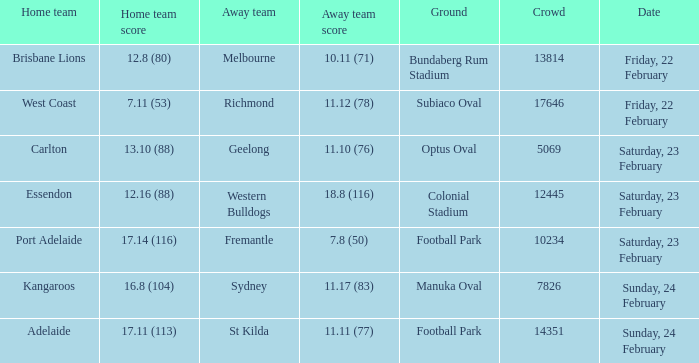Where the home team scored 13.10 (88), what was the size of the crowd? 5069.0. Parse the table in full. {'header': ['Home team', 'Home team score', 'Away team', 'Away team score', 'Ground', 'Crowd', 'Date'], 'rows': [['Brisbane Lions', '12.8 (80)', 'Melbourne', '10.11 (71)', 'Bundaberg Rum Stadium', '13814', 'Friday, 22 February'], ['West Coast', '7.11 (53)', 'Richmond', '11.12 (78)', 'Subiaco Oval', '17646', 'Friday, 22 February'], ['Carlton', '13.10 (88)', 'Geelong', '11.10 (76)', 'Optus Oval', '5069', 'Saturday, 23 February'], ['Essendon', '12.16 (88)', 'Western Bulldogs', '18.8 (116)', 'Colonial Stadium', '12445', 'Saturday, 23 February'], ['Port Adelaide', '17.14 (116)', 'Fremantle', '7.8 (50)', 'Football Park', '10234', 'Saturday, 23 February'], ['Kangaroos', '16.8 (104)', 'Sydney', '11.17 (83)', 'Manuka Oval', '7826', 'Sunday, 24 February'], ['Adelaide', '17.11 (113)', 'St Kilda', '11.11 (77)', 'Football Park', '14351', 'Sunday, 24 February']]} 